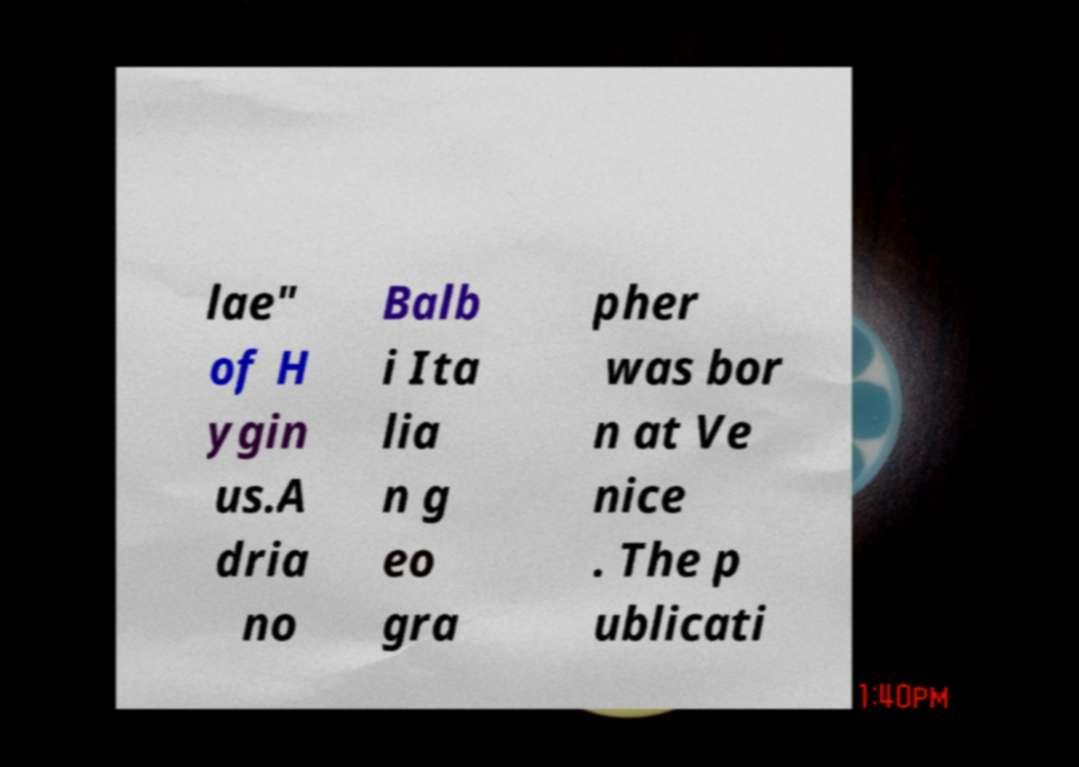Can you accurately transcribe the text from the provided image for me? lae" of H ygin us.A dria no Balb i Ita lia n g eo gra pher was bor n at Ve nice . The p ublicati 